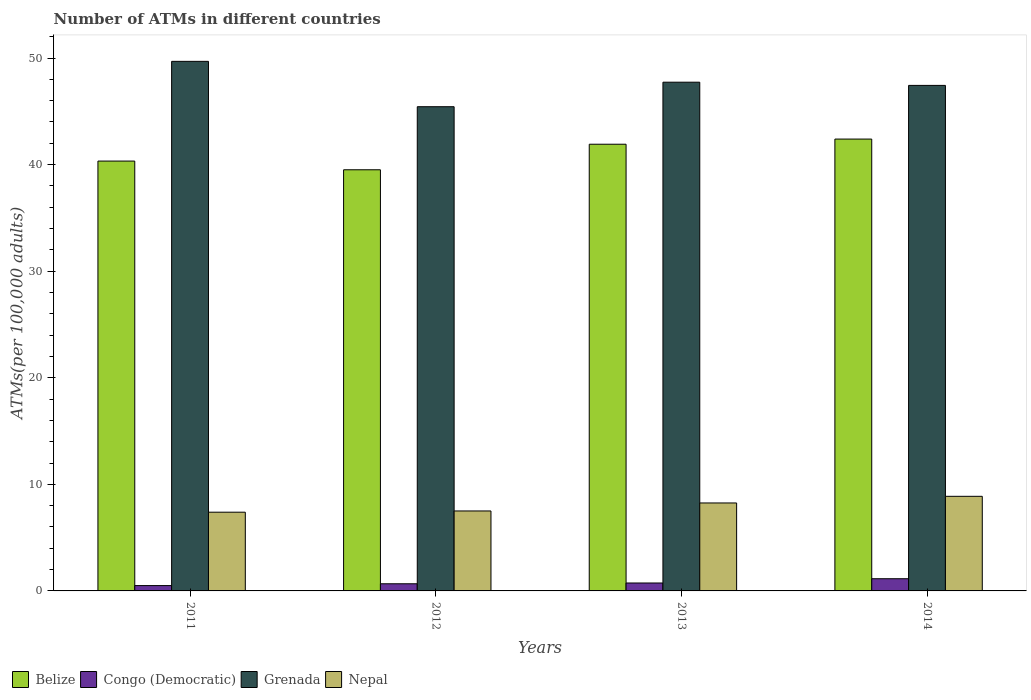How many different coloured bars are there?
Your answer should be very brief. 4. How many groups of bars are there?
Provide a succinct answer. 4. Are the number of bars per tick equal to the number of legend labels?
Your answer should be very brief. Yes. How many bars are there on the 3rd tick from the right?
Ensure brevity in your answer.  4. What is the label of the 4th group of bars from the left?
Provide a short and direct response. 2014. In how many cases, is the number of bars for a given year not equal to the number of legend labels?
Provide a short and direct response. 0. What is the number of ATMs in Nepal in 2011?
Your response must be concise. 7.39. Across all years, what is the maximum number of ATMs in Congo (Democratic)?
Give a very brief answer. 1.14. Across all years, what is the minimum number of ATMs in Grenada?
Your answer should be compact. 45.43. In which year was the number of ATMs in Grenada minimum?
Ensure brevity in your answer.  2012. What is the total number of ATMs in Belize in the graph?
Offer a terse response. 164.15. What is the difference between the number of ATMs in Belize in 2013 and that in 2014?
Offer a very short reply. -0.48. What is the difference between the number of ATMs in Grenada in 2014 and the number of ATMs in Nepal in 2012?
Your answer should be compact. 39.93. What is the average number of ATMs in Belize per year?
Keep it short and to the point. 41.04. In the year 2014, what is the difference between the number of ATMs in Belize and number of ATMs in Congo (Democratic)?
Make the answer very short. 41.25. In how many years, is the number of ATMs in Grenada greater than 36?
Your response must be concise. 4. What is the ratio of the number of ATMs in Belize in 2011 to that in 2013?
Offer a very short reply. 0.96. Is the number of ATMs in Congo (Democratic) in 2011 less than that in 2012?
Ensure brevity in your answer.  Yes. What is the difference between the highest and the second highest number of ATMs in Congo (Democratic)?
Offer a terse response. 0.4. What is the difference between the highest and the lowest number of ATMs in Grenada?
Ensure brevity in your answer.  4.26. What does the 1st bar from the left in 2014 represents?
Make the answer very short. Belize. What does the 1st bar from the right in 2013 represents?
Offer a terse response. Nepal. Are all the bars in the graph horizontal?
Offer a very short reply. No. What is the difference between two consecutive major ticks on the Y-axis?
Make the answer very short. 10. Are the values on the major ticks of Y-axis written in scientific E-notation?
Offer a very short reply. No. Where does the legend appear in the graph?
Your response must be concise. Bottom left. How many legend labels are there?
Provide a succinct answer. 4. How are the legend labels stacked?
Provide a succinct answer. Horizontal. What is the title of the graph?
Make the answer very short. Number of ATMs in different countries. Does "St. Kitts and Nevis" appear as one of the legend labels in the graph?
Your answer should be compact. No. What is the label or title of the Y-axis?
Ensure brevity in your answer.  ATMs(per 100,0 adults). What is the ATMs(per 100,000 adults) in Belize in 2011?
Keep it short and to the point. 40.33. What is the ATMs(per 100,000 adults) of Congo (Democratic) in 2011?
Offer a terse response. 0.5. What is the ATMs(per 100,000 adults) of Grenada in 2011?
Provide a succinct answer. 49.69. What is the ATMs(per 100,000 adults) in Nepal in 2011?
Ensure brevity in your answer.  7.39. What is the ATMs(per 100,000 adults) in Belize in 2012?
Provide a succinct answer. 39.51. What is the ATMs(per 100,000 adults) of Congo (Democratic) in 2012?
Give a very brief answer. 0.67. What is the ATMs(per 100,000 adults) in Grenada in 2012?
Keep it short and to the point. 45.43. What is the ATMs(per 100,000 adults) of Nepal in 2012?
Offer a terse response. 7.5. What is the ATMs(per 100,000 adults) of Belize in 2013?
Provide a succinct answer. 41.91. What is the ATMs(per 100,000 adults) in Congo (Democratic) in 2013?
Keep it short and to the point. 0.74. What is the ATMs(per 100,000 adults) of Grenada in 2013?
Provide a succinct answer. 47.73. What is the ATMs(per 100,000 adults) in Nepal in 2013?
Your answer should be very brief. 8.25. What is the ATMs(per 100,000 adults) of Belize in 2014?
Keep it short and to the point. 42.39. What is the ATMs(per 100,000 adults) of Congo (Democratic) in 2014?
Make the answer very short. 1.14. What is the ATMs(per 100,000 adults) in Grenada in 2014?
Keep it short and to the point. 47.43. What is the ATMs(per 100,000 adults) in Nepal in 2014?
Give a very brief answer. 8.88. Across all years, what is the maximum ATMs(per 100,000 adults) in Belize?
Keep it short and to the point. 42.39. Across all years, what is the maximum ATMs(per 100,000 adults) of Congo (Democratic)?
Provide a short and direct response. 1.14. Across all years, what is the maximum ATMs(per 100,000 adults) in Grenada?
Provide a succinct answer. 49.69. Across all years, what is the maximum ATMs(per 100,000 adults) of Nepal?
Offer a terse response. 8.88. Across all years, what is the minimum ATMs(per 100,000 adults) of Belize?
Make the answer very short. 39.51. Across all years, what is the minimum ATMs(per 100,000 adults) of Congo (Democratic)?
Your answer should be compact. 0.5. Across all years, what is the minimum ATMs(per 100,000 adults) of Grenada?
Provide a short and direct response. 45.43. Across all years, what is the minimum ATMs(per 100,000 adults) in Nepal?
Ensure brevity in your answer.  7.39. What is the total ATMs(per 100,000 adults) in Belize in the graph?
Make the answer very short. 164.15. What is the total ATMs(per 100,000 adults) in Congo (Democratic) in the graph?
Give a very brief answer. 3.06. What is the total ATMs(per 100,000 adults) in Grenada in the graph?
Your response must be concise. 190.28. What is the total ATMs(per 100,000 adults) of Nepal in the graph?
Provide a short and direct response. 32.02. What is the difference between the ATMs(per 100,000 adults) in Belize in 2011 and that in 2012?
Offer a terse response. 0.82. What is the difference between the ATMs(per 100,000 adults) of Congo (Democratic) in 2011 and that in 2012?
Your answer should be compact. -0.17. What is the difference between the ATMs(per 100,000 adults) in Grenada in 2011 and that in 2012?
Provide a succinct answer. 4.26. What is the difference between the ATMs(per 100,000 adults) of Nepal in 2011 and that in 2012?
Make the answer very short. -0.12. What is the difference between the ATMs(per 100,000 adults) in Belize in 2011 and that in 2013?
Ensure brevity in your answer.  -1.58. What is the difference between the ATMs(per 100,000 adults) of Congo (Democratic) in 2011 and that in 2013?
Offer a very short reply. -0.24. What is the difference between the ATMs(per 100,000 adults) of Grenada in 2011 and that in 2013?
Ensure brevity in your answer.  1.96. What is the difference between the ATMs(per 100,000 adults) of Nepal in 2011 and that in 2013?
Your answer should be compact. -0.87. What is the difference between the ATMs(per 100,000 adults) in Belize in 2011 and that in 2014?
Provide a short and direct response. -2.06. What is the difference between the ATMs(per 100,000 adults) in Congo (Democratic) in 2011 and that in 2014?
Provide a succinct answer. -0.64. What is the difference between the ATMs(per 100,000 adults) in Grenada in 2011 and that in 2014?
Give a very brief answer. 2.26. What is the difference between the ATMs(per 100,000 adults) of Nepal in 2011 and that in 2014?
Offer a very short reply. -1.49. What is the difference between the ATMs(per 100,000 adults) of Belize in 2012 and that in 2013?
Keep it short and to the point. -2.4. What is the difference between the ATMs(per 100,000 adults) in Congo (Democratic) in 2012 and that in 2013?
Your answer should be compact. -0.07. What is the difference between the ATMs(per 100,000 adults) of Grenada in 2012 and that in 2013?
Your answer should be very brief. -2.3. What is the difference between the ATMs(per 100,000 adults) of Nepal in 2012 and that in 2013?
Give a very brief answer. -0.75. What is the difference between the ATMs(per 100,000 adults) in Belize in 2012 and that in 2014?
Ensure brevity in your answer.  -2.88. What is the difference between the ATMs(per 100,000 adults) of Congo (Democratic) in 2012 and that in 2014?
Offer a very short reply. -0.47. What is the difference between the ATMs(per 100,000 adults) in Grenada in 2012 and that in 2014?
Offer a very short reply. -2. What is the difference between the ATMs(per 100,000 adults) of Nepal in 2012 and that in 2014?
Provide a short and direct response. -1.37. What is the difference between the ATMs(per 100,000 adults) of Belize in 2013 and that in 2014?
Offer a terse response. -0.48. What is the difference between the ATMs(per 100,000 adults) in Congo (Democratic) in 2013 and that in 2014?
Ensure brevity in your answer.  -0.4. What is the difference between the ATMs(per 100,000 adults) of Grenada in 2013 and that in 2014?
Give a very brief answer. 0.3. What is the difference between the ATMs(per 100,000 adults) in Nepal in 2013 and that in 2014?
Your answer should be compact. -0.62. What is the difference between the ATMs(per 100,000 adults) of Belize in 2011 and the ATMs(per 100,000 adults) of Congo (Democratic) in 2012?
Your answer should be compact. 39.66. What is the difference between the ATMs(per 100,000 adults) of Belize in 2011 and the ATMs(per 100,000 adults) of Grenada in 2012?
Offer a terse response. -5.1. What is the difference between the ATMs(per 100,000 adults) of Belize in 2011 and the ATMs(per 100,000 adults) of Nepal in 2012?
Offer a very short reply. 32.83. What is the difference between the ATMs(per 100,000 adults) in Congo (Democratic) in 2011 and the ATMs(per 100,000 adults) in Grenada in 2012?
Keep it short and to the point. -44.93. What is the difference between the ATMs(per 100,000 adults) of Congo (Democratic) in 2011 and the ATMs(per 100,000 adults) of Nepal in 2012?
Offer a terse response. -7. What is the difference between the ATMs(per 100,000 adults) of Grenada in 2011 and the ATMs(per 100,000 adults) of Nepal in 2012?
Your answer should be compact. 42.18. What is the difference between the ATMs(per 100,000 adults) in Belize in 2011 and the ATMs(per 100,000 adults) in Congo (Democratic) in 2013?
Make the answer very short. 39.59. What is the difference between the ATMs(per 100,000 adults) of Belize in 2011 and the ATMs(per 100,000 adults) of Grenada in 2013?
Offer a terse response. -7.4. What is the difference between the ATMs(per 100,000 adults) in Belize in 2011 and the ATMs(per 100,000 adults) in Nepal in 2013?
Offer a terse response. 32.08. What is the difference between the ATMs(per 100,000 adults) of Congo (Democratic) in 2011 and the ATMs(per 100,000 adults) of Grenada in 2013?
Keep it short and to the point. -47.23. What is the difference between the ATMs(per 100,000 adults) of Congo (Democratic) in 2011 and the ATMs(per 100,000 adults) of Nepal in 2013?
Make the answer very short. -7.75. What is the difference between the ATMs(per 100,000 adults) in Grenada in 2011 and the ATMs(per 100,000 adults) in Nepal in 2013?
Provide a succinct answer. 41.43. What is the difference between the ATMs(per 100,000 adults) in Belize in 2011 and the ATMs(per 100,000 adults) in Congo (Democratic) in 2014?
Provide a short and direct response. 39.19. What is the difference between the ATMs(per 100,000 adults) of Belize in 2011 and the ATMs(per 100,000 adults) of Grenada in 2014?
Provide a short and direct response. -7.1. What is the difference between the ATMs(per 100,000 adults) in Belize in 2011 and the ATMs(per 100,000 adults) in Nepal in 2014?
Offer a terse response. 31.45. What is the difference between the ATMs(per 100,000 adults) of Congo (Democratic) in 2011 and the ATMs(per 100,000 adults) of Grenada in 2014?
Provide a succinct answer. -46.93. What is the difference between the ATMs(per 100,000 adults) in Congo (Democratic) in 2011 and the ATMs(per 100,000 adults) in Nepal in 2014?
Make the answer very short. -8.38. What is the difference between the ATMs(per 100,000 adults) in Grenada in 2011 and the ATMs(per 100,000 adults) in Nepal in 2014?
Offer a very short reply. 40.81. What is the difference between the ATMs(per 100,000 adults) of Belize in 2012 and the ATMs(per 100,000 adults) of Congo (Democratic) in 2013?
Your answer should be very brief. 38.77. What is the difference between the ATMs(per 100,000 adults) of Belize in 2012 and the ATMs(per 100,000 adults) of Grenada in 2013?
Provide a short and direct response. -8.22. What is the difference between the ATMs(per 100,000 adults) of Belize in 2012 and the ATMs(per 100,000 adults) of Nepal in 2013?
Offer a terse response. 31.26. What is the difference between the ATMs(per 100,000 adults) of Congo (Democratic) in 2012 and the ATMs(per 100,000 adults) of Grenada in 2013?
Offer a terse response. -47.06. What is the difference between the ATMs(per 100,000 adults) of Congo (Democratic) in 2012 and the ATMs(per 100,000 adults) of Nepal in 2013?
Your answer should be very brief. -7.58. What is the difference between the ATMs(per 100,000 adults) in Grenada in 2012 and the ATMs(per 100,000 adults) in Nepal in 2013?
Provide a short and direct response. 37.18. What is the difference between the ATMs(per 100,000 adults) of Belize in 2012 and the ATMs(per 100,000 adults) of Congo (Democratic) in 2014?
Offer a terse response. 38.37. What is the difference between the ATMs(per 100,000 adults) in Belize in 2012 and the ATMs(per 100,000 adults) in Grenada in 2014?
Your answer should be compact. -7.92. What is the difference between the ATMs(per 100,000 adults) of Belize in 2012 and the ATMs(per 100,000 adults) of Nepal in 2014?
Make the answer very short. 30.64. What is the difference between the ATMs(per 100,000 adults) of Congo (Democratic) in 2012 and the ATMs(per 100,000 adults) of Grenada in 2014?
Keep it short and to the point. -46.76. What is the difference between the ATMs(per 100,000 adults) of Congo (Democratic) in 2012 and the ATMs(per 100,000 adults) of Nepal in 2014?
Ensure brevity in your answer.  -8.2. What is the difference between the ATMs(per 100,000 adults) of Grenada in 2012 and the ATMs(per 100,000 adults) of Nepal in 2014?
Offer a terse response. 36.55. What is the difference between the ATMs(per 100,000 adults) of Belize in 2013 and the ATMs(per 100,000 adults) of Congo (Democratic) in 2014?
Ensure brevity in your answer.  40.77. What is the difference between the ATMs(per 100,000 adults) in Belize in 2013 and the ATMs(per 100,000 adults) in Grenada in 2014?
Ensure brevity in your answer.  -5.52. What is the difference between the ATMs(per 100,000 adults) in Belize in 2013 and the ATMs(per 100,000 adults) in Nepal in 2014?
Give a very brief answer. 33.03. What is the difference between the ATMs(per 100,000 adults) in Congo (Democratic) in 2013 and the ATMs(per 100,000 adults) in Grenada in 2014?
Offer a terse response. -46.69. What is the difference between the ATMs(per 100,000 adults) of Congo (Democratic) in 2013 and the ATMs(per 100,000 adults) of Nepal in 2014?
Your answer should be compact. -8.13. What is the difference between the ATMs(per 100,000 adults) in Grenada in 2013 and the ATMs(per 100,000 adults) in Nepal in 2014?
Make the answer very short. 38.85. What is the average ATMs(per 100,000 adults) in Belize per year?
Your response must be concise. 41.04. What is the average ATMs(per 100,000 adults) of Congo (Democratic) per year?
Ensure brevity in your answer.  0.76. What is the average ATMs(per 100,000 adults) in Grenada per year?
Provide a short and direct response. 47.57. What is the average ATMs(per 100,000 adults) of Nepal per year?
Your answer should be compact. 8. In the year 2011, what is the difference between the ATMs(per 100,000 adults) in Belize and ATMs(per 100,000 adults) in Congo (Democratic)?
Your response must be concise. 39.83. In the year 2011, what is the difference between the ATMs(per 100,000 adults) of Belize and ATMs(per 100,000 adults) of Grenada?
Your response must be concise. -9.36. In the year 2011, what is the difference between the ATMs(per 100,000 adults) of Belize and ATMs(per 100,000 adults) of Nepal?
Make the answer very short. 32.94. In the year 2011, what is the difference between the ATMs(per 100,000 adults) in Congo (Democratic) and ATMs(per 100,000 adults) in Grenada?
Provide a short and direct response. -49.19. In the year 2011, what is the difference between the ATMs(per 100,000 adults) of Congo (Democratic) and ATMs(per 100,000 adults) of Nepal?
Keep it short and to the point. -6.89. In the year 2011, what is the difference between the ATMs(per 100,000 adults) of Grenada and ATMs(per 100,000 adults) of Nepal?
Ensure brevity in your answer.  42.3. In the year 2012, what is the difference between the ATMs(per 100,000 adults) in Belize and ATMs(per 100,000 adults) in Congo (Democratic)?
Keep it short and to the point. 38.84. In the year 2012, what is the difference between the ATMs(per 100,000 adults) in Belize and ATMs(per 100,000 adults) in Grenada?
Provide a short and direct response. -5.92. In the year 2012, what is the difference between the ATMs(per 100,000 adults) of Belize and ATMs(per 100,000 adults) of Nepal?
Make the answer very short. 32.01. In the year 2012, what is the difference between the ATMs(per 100,000 adults) in Congo (Democratic) and ATMs(per 100,000 adults) in Grenada?
Make the answer very short. -44.76. In the year 2012, what is the difference between the ATMs(per 100,000 adults) in Congo (Democratic) and ATMs(per 100,000 adults) in Nepal?
Offer a very short reply. -6.83. In the year 2012, what is the difference between the ATMs(per 100,000 adults) of Grenada and ATMs(per 100,000 adults) of Nepal?
Give a very brief answer. 37.93. In the year 2013, what is the difference between the ATMs(per 100,000 adults) in Belize and ATMs(per 100,000 adults) in Congo (Democratic)?
Keep it short and to the point. 41.17. In the year 2013, what is the difference between the ATMs(per 100,000 adults) in Belize and ATMs(per 100,000 adults) in Grenada?
Your answer should be very brief. -5.82. In the year 2013, what is the difference between the ATMs(per 100,000 adults) in Belize and ATMs(per 100,000 adults) in Nepal?
Offer a terse response. 33.66. In the year 2013, what is the difference between the ATMs(per 100,000 adults) in Congo (Democratic) and ATMs(per 100,000 adults) in Grenada?
Your answer should be compact. -46.99. In the year 2013, what is the difference between the ATMs(per 100,000 adults) in Congo (Democratic) and ATMs(per 100,000 adults) in Nepal?
Give a very brief answer. -7.51. In the year 2013, what is the difference between the ATMs(per 100,000 adults) of Grenada and ATMs(per 100,000 adults) of Nepal?
Provide a short and direct response. 39.48. In the year 2014, what is the difference between the ATMs(per 100,000 adults) in Belize and ATMs(per 100,000 adults) in Congo (Democratic)?
Offer a very short reply. 41.25. In the year 2014, what is the difference between the ATMs(per 100,000 adults) of Belize and ATMs(per 100,000 adults) of Grenada?
Make the answer very short. -5.04. In the year 2014, what is the difference between the ATMs(per 100,000 adults) of Belize and ATMs(per 100,000 adults) of Nepal?
Ensure brevity in your answer.  33.52. In the year 2014, what is the difference between the ATMs(per 100,000 adults) of Congo (Democratic) and ATMs(per 100,000 adults) of Grenada?
Give a very brief answer. -46.29. In the year 2014, what is the difference between the ATMs(per 100,000 adults) of Congo (Democratic) and ATMs(per 100,000 adults) of Nepal?
Give a very brief answer. -7.73. In the year 2014, what is the difference between the ATMs(per 100,000 adults) of Grenada and ATMs(per 100,000 adults) of Nepal?
Keep it short and to the point. 38.55. What is the ratio of the ATMs(per 100,000 adults) of Belize in 2011 to that in 2012?
Ensure brevity in your answer.  1.02. What is the ratio of the ATMs(per 100,000 adults) of Congo (Democratic) in 2011 to that in 2012?
Offer a very short reply. 0.75. What is the ratio of the ATMs(per 100,000 adults) in Grenada in 2011 to that in 2012?
Make the answer very short. 1.09. What is the ratio of the ATMs(per 100,000 adults) of Nepal in 2011 to that in 2012?
Make the answer very short. 0.98. What is the ratio of the ATMs(per 100,000 adults) of Belize in 2011 to that in 2013?
Provide a succinct answer. 0.96. What is the ratio of the ATMs(per 100,000 adults) of Congo (Democratic) in 2011 to that in 2013?
Offer a very short reply. 0.67. What is the ratio of the ATMs(per 100,000 adults) in Grenada in 2011 to that in 2013?
Keep it short and to the point. 1.04. What is the ratio of the ATMs(per 100,000 adults) in Nepal in 2011 to that in 2013?
Provide a succinct answer. 0.9. What is the ratio of the ATMs(per 100,000 adults) in Belize in 2011 to that in 2014?
Offer a terse response. 0.95. What is the ratio of the ATMs(per 100,000 adults) of Congo (Democratic) in 2011 to that in 2014?
Provide a short and direct response. 0.44. What is the ratio of the ATMs(per 100,000 adults) in Grenada in 2011 to that in 2014?
Offer a terse response. 1.05. What is the ratio of the ATMs(per 100,000 adults) of Nepal in 2011 to that in 2014?
Offer a terse response. 0.83. What is the ratio of the ATMs(per 100,000 adults) of Belize in 2012 to that in 2013?
Give a very brief answer. 0.94. What is the ratio of the ATMs(per 100,000 adults) in Congo (Democratic) in 2012 to that in 2013?
Offer a very short reply. 0.9. What is the ratio of the ATMs(per 100,000 adults) in Grenada in 2012 to that in 2013?
Provide a succinct answer. 0.95. What is the ratio of the ATMs(per 100,000 adults) in Nepal in 2012 to that in 2013?
Ensure brevity in your answer.  0.91. What is the ratio of the ATMs(per 100,000 adults) of Belize in 2012 to that in 2014?
Ensure brevity in your answer.  0.93. What is the ratio of the ATMs(per 100,000 adults) of Congo (Democratic) in 2012 to that in 2014?
Offer a very short reply. 0.59. What is the ratio of the ATMs(per 100,000 adults) of Grenada in 2012 to that in 2014?
Provide a succinct answer. 0.96. What is the ratio of the ATMs(per 100,000 adults) in Nepal in 2012 to that in 2014?
Provide a short and direct response. 0.85. What is the ratio of the ATMs(per 100,000 adults) in Belize in 2013 to that in 2014?
Your response must be concise. 0.99. What is the ratio of the ATMs(per 100,000 adults) in Congo (Democratic) in 2013 to that in 2014?
Provide a short and direct response. 0.65. What is the ratio of the ATMs(per 100,000 adults) of Nepal in 2013 to that in 2014?
Your response must be concise. 0.93. What is the difference between the highest and the second highest ATMs(per 100,000 adults) of Belize?
Your response must be concise. 0.48. What is the difference between the highest and the second highest ATMs(per 100,000 adults) in Congo (Democratic)?
Your answer should be compact. 0.4. What is the difference between the highest and the second highest ATMs(per 100,000 adults) in Grenada?
Your response must be concise. 1.96. What is the difference between the highest and the second highest ATMs(per 100,000 adults) of Nepal?
Keep it short and to the point. 0.62. What is the difference between the highest and the lowest ATMs(per 100,000 adults) in Belize?
Provide a succinct answer. 2.88. What is the difference between the highest and the lowest ATMs(per 100,000 adults) of Congo (Democratic)?
Provide a short and direct response. 0.64. What is the difference between the highest and the lowest ATMs(per 100,000 adults) in Grenada?
Your answer should be compact. 4.26. What is the difference between the highest and the lowest ATMs(per 100,000 adults) in Nepal?
Provide a short and direct response. 1.49. 